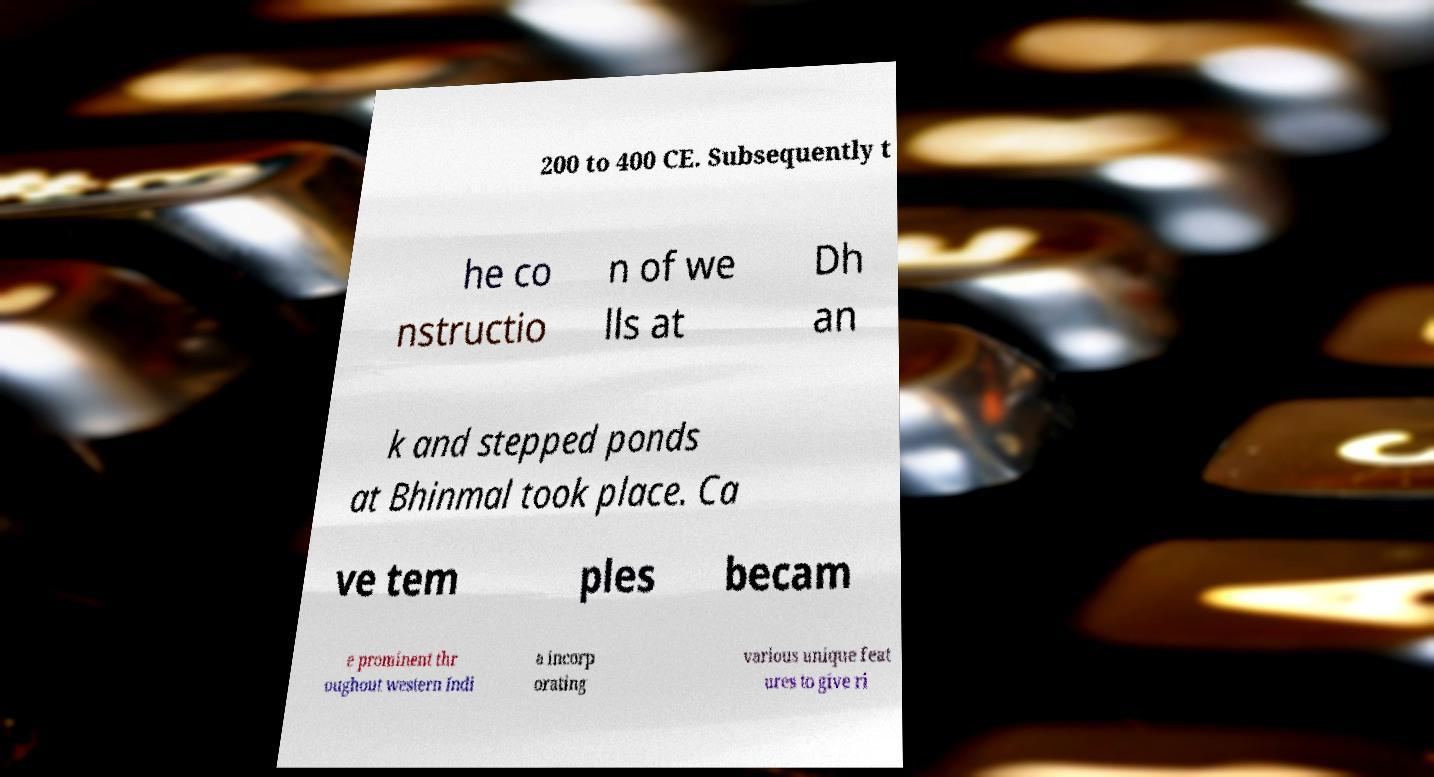Could you assist in decoding the text presented in this image and type it out clearly? 200 to 400 CE. Subsequently t he co nstructio n of we lls at Dh an k and stepped ponds at Bhinmal took place. Ca ve tem ples becam e prominent thr oughout western Indi a incorp orating various unique feat ures to give ri 